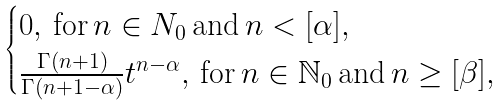<formula> <loc_0><loc_0><loc_500><loc_500>\begin{cases} 0 , \, \text {for} \, n \in N _ { 0 } \, \text {and} \, n < [ \alpha ] , \\ \frac { \Gamma ( n + 1 ) } { \Gamma ( n + 1 - \alpha ) } t ^ { n - \alpha } , \, \text {for} \, n \in \mathbb { N } _ { 0 } \, \text {and} \, n \geq [ \beta ] , \end{cases}</formula> 